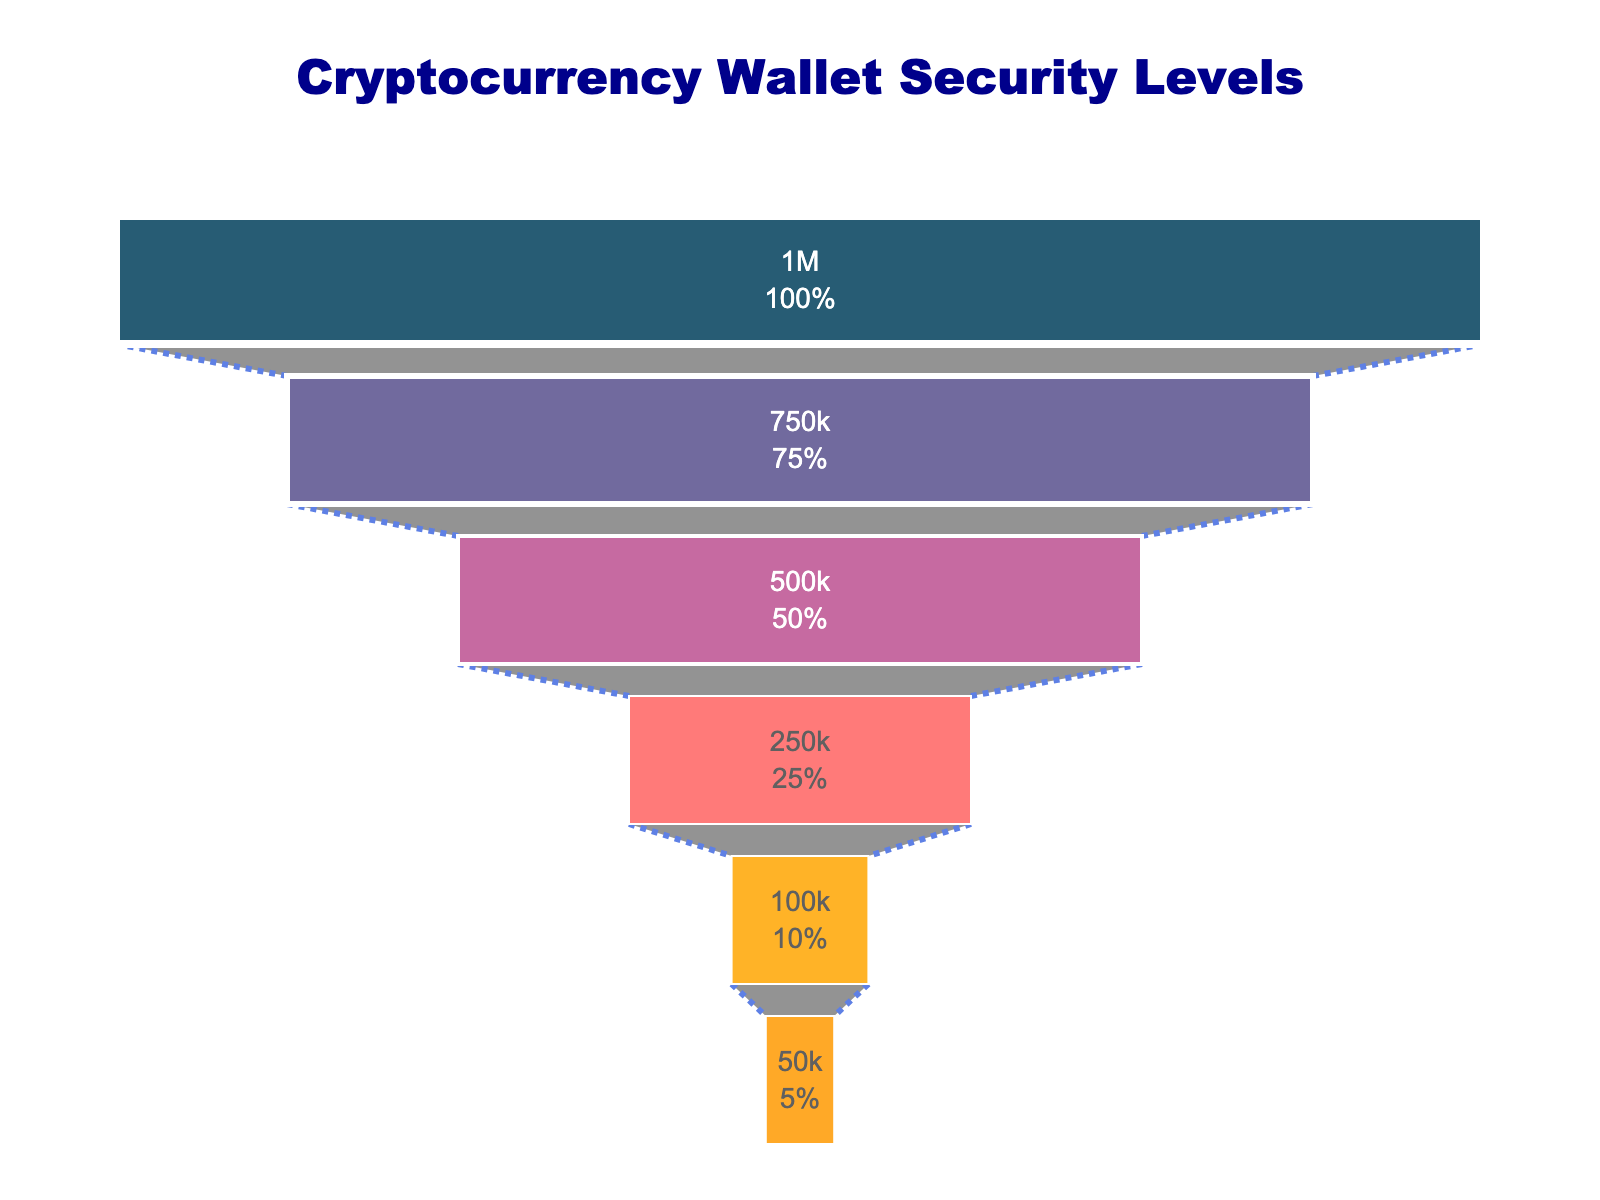What is the title of the chart? The title is prominently visible at the top of the chart. It reads "Cryptocurrency Wallet Security Levels".
Answer: Cryptocurrency Wallet Security Levels How many security levels are shown in the chart? The chart lists all security levels on the Y-axis. Counting these entries gives us a total of six.
Answer: Six Which security tier has the most users? The bar representing "Basic Password Protection" is the longest among all, indicating it has the highest number of users.
Answer: Basic Password Protection How many users use Hardware Wallets? The bar labeled "Hardware Wallet" has a value shown within it representing the number of users. The number depicted there is 500,000.
Answer: 500,000 What percentage of initial users have Two-Factor Authentication? The bar representing "Two-Factor Authentication (2FA)" includes the percentage of initial users within the bar itself. This value is 75%.
Answer: 75% What is the difference in user count between Basic Password Protection and Cold Storage? Subtract the number of Cold Storage users (100,000) from the number of Basic Password Protection users (1,000,000). \(1,000,000 - 100,000 = 900,000\).
Answer: 900,000 Which security level has the fewest users? The smallest bar in the chart represents "Air-Gapped Cold Storage," indicating it has the least number of users.
Answer: Air-Gapped Cold Storage What is the combined total number of users with security levels of Multi-Signature Wallet and Cold Storage? Add the number of Multi-Signature Wallet users (250,000) to the number of Cold Storage users (100,000). \(250,000 + 100,000 = 350,000\).
Answer: 350,000 How does the percentage drop from Two-Factor Authentication to Hardware Wallet compare to the percentage drop from Multi-Signature Wallet to Cold Storage? The percentage drop from Two-Factor Authentication (75%) to Hardware Wallet (50%) is \(75% - 50% = 25%\). The percentage drop from Multi-Signature Wallet (25%) to Cold Storage (10%) is \(25% - 10% = 15%\). So, the drop from Two-Factor Authentication to Hardware Wallet (25%) is greater than the drop from Multi-Signature Wallet to Cold Storage (15%).
Answer: 25% is greater than 15% What's the average number of users across all security levels? Sum all users: \(1,000,000 + 750,000 + 500,000 + 250,000 + 100,000 + 50,000 = 2,650,000\). Then divide by the number of security levels (6). \(2,650,000 / 6 \approx 441,667\).
Answer: 441,667 